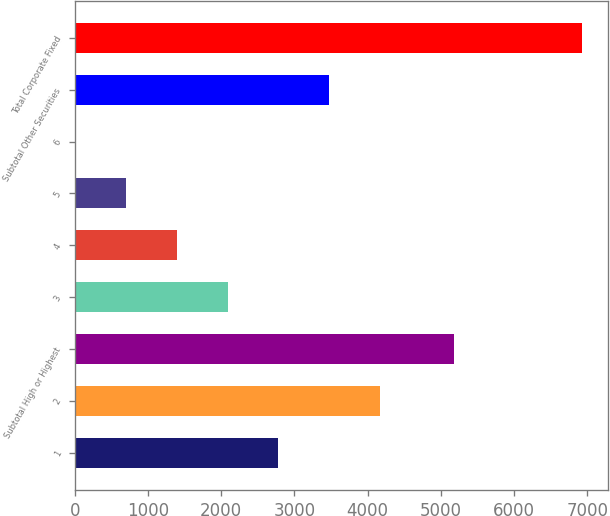Convert chart to OTSL. <chart><loc_0><loc_0><loc_500><loc_500><bar_chart><fcel>1<fcel>2<fcel>Subtotal High or Highest<fcel>3<fcel>4<fcel>5<fcel>6<fcel>Subtotal Other Securities<fcel>Total Corporate Fixed<nl><fcel>2781.4<fcel>4164.6<fcel>5173<fcel>2089.8<fcel>1398.2<fcel>706.6<fcel>15<fcel>3473<fcel>6931<nl></chart> 